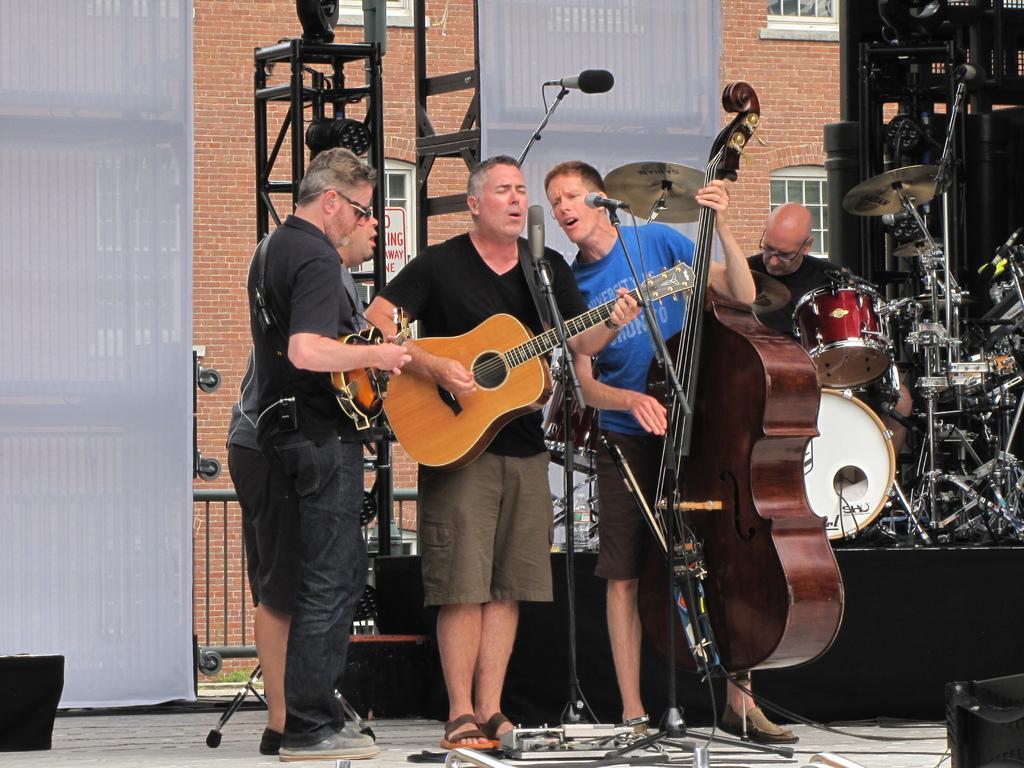Can you describe this image briefly? In this image I see 5 men, in which 4 of them are with the instruments and 2 of them are near the mics. In the background I see the building. 